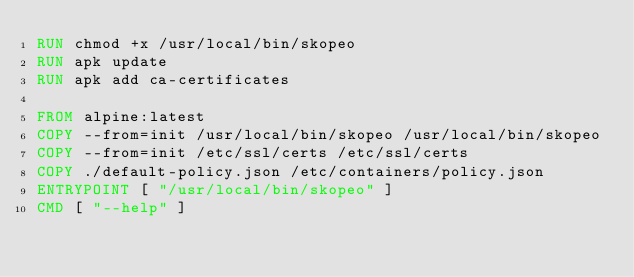Convert code to text. <code><loc_0><loc_0><loc_500><loc_500><_Dockerfile_>RUN chmod +x /usr/local/bin/skopeo
RUN apk update
RUN apk add ca-certificates

FROM alpine:latest
COPY --from=init /usr/local/bin/skopeo /usr/local/bin/skopeo
COPY --from=init /etc/ssl/certs /etc/ssl/certs
COPY ./default-policy.json /etc/containers/policy.json
ENTRYPOINT [ "/usr/local/bin/skopeo" ]
CMD [ "--help" ]</code> 